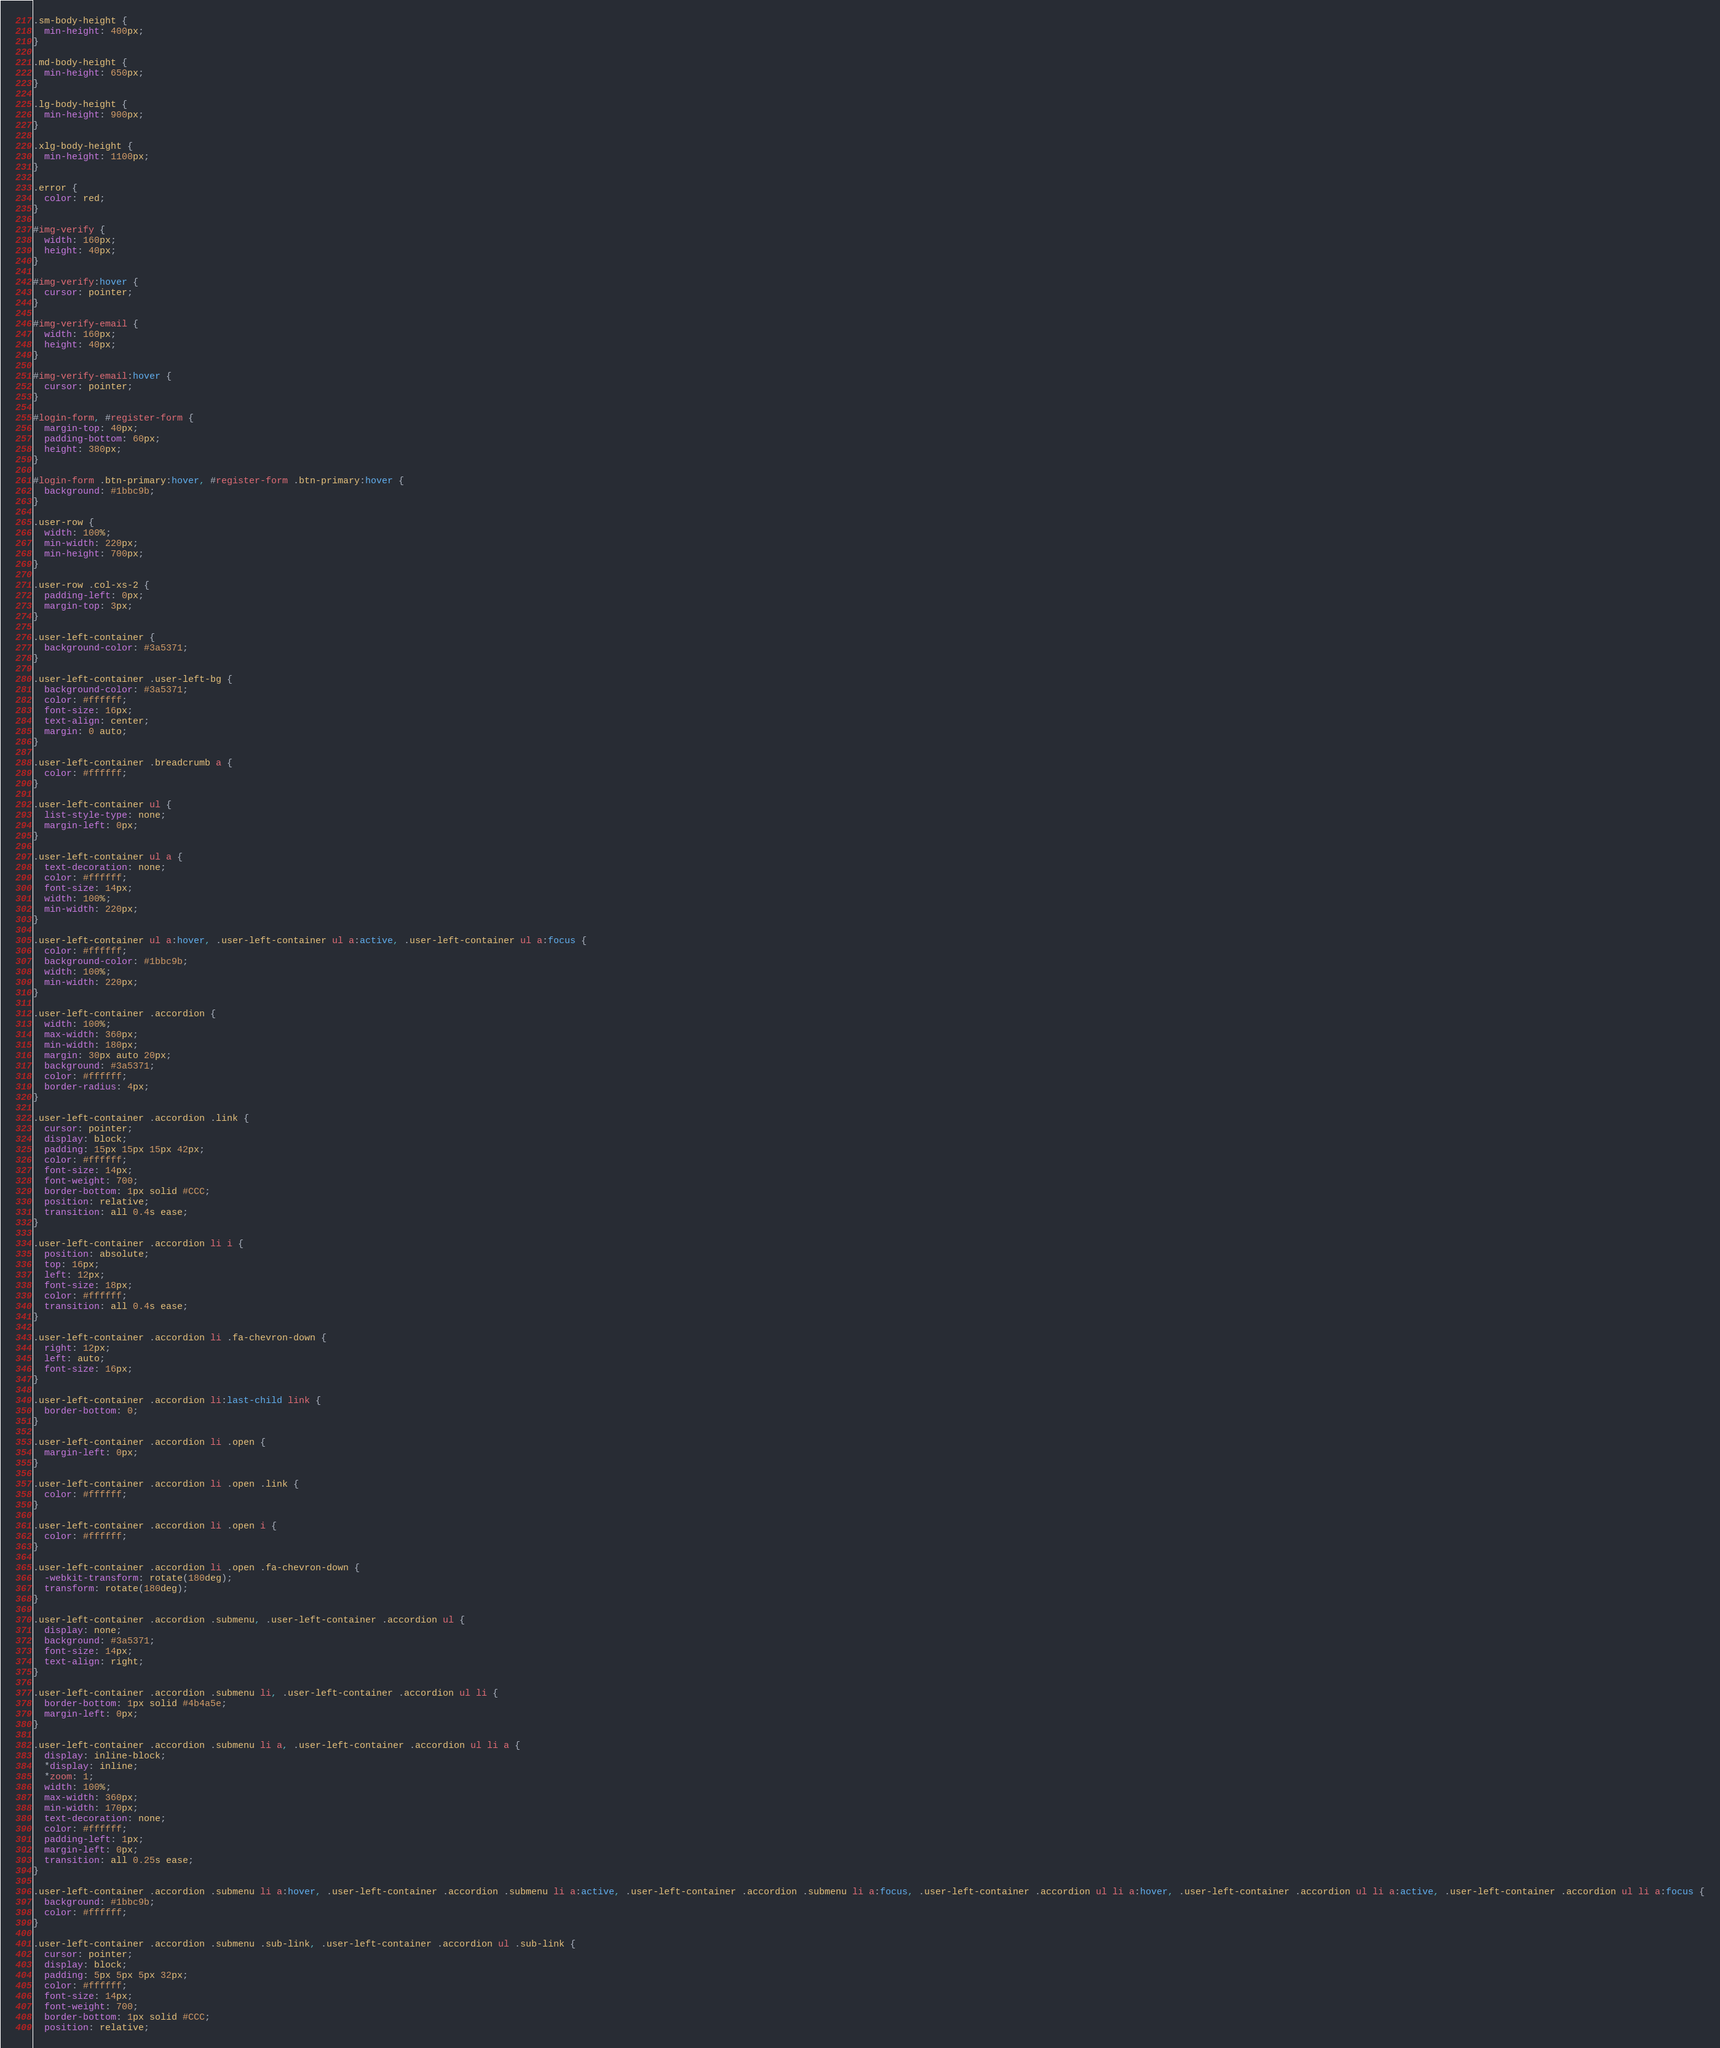Convert code to text. <code><loc_0><loc_0><loc_500><loc_500><_CSS_>.sm-body-height {
  min-height: 400px;
}

.md-body-height {
  min-height: 650px;
}

.lg-body-height {
  min-height: 900px;
}

.xlg-body-height {
  min-height: 1100px;
}

.error {
  color: red;
}

#img-verify {
  width: 160px;
  height: 40px;
}

#img-verify:hover {
  cursor: pointer;
}

#img-verify-email {
  width: 160px;
  height: 40px;
}

#img-verify-email:hover {
  cursor: pointer;
}

#login-form, #register-form {
  margin-top: 40px;
  padding-bottom: 60px;
  height: 380px;
}

#login-form .btn-primary:hover, #register-form .btn-primary:hover {
  background: #1bbc9b;
}

.user-row {
  width: 100%;
  min-width: 220px;
  min-height: 700px;
}

.user-row .col-xs-2 {
  padding-left: 0px;
  margin-top: 3px;
}

.user-left-container {
  background-color: #3a5371;
}

.user-left-container .user-left-bg {
  background-color: #3a5371;
  color: #ffffff;
  font-size: 16px;
  text-align: center;
  margin: 0 auto;
}

.user-left-container .breadcrumb a {
  color: #ffffff;
}

.user-left-container ul {
  list-style-type: none;
  margin-left: 0px;
}

.user-left-container ul a {
  text-decoration: none;
  color: #ffffff;
  font-size: 14px;
  width: 100%;
  min-width: 220px;
}

.user-left-container ul a:hover, .user-left-container ul a:active, .user-left-container ul a:focus {
  color: #ffffff;
  background-color: #1bbc9b;
  width: 100%;
  min-width: 220px;
}

.user-left-container .accordion {
  width: 100%;
  max-width: 360px;
  min-width: 180px;
  margin: 30px auto 20px;
  background: #3a5371;
  color: #ffffff;
  border-radius: 4px;
}

.user-left-container .accordion .link {
  cursor: pointer;
  display: block;
  padding: 15px 15px 15px 42px;
  color: #ffffff;
  font-size: 14px;
  font-weight: 700;
  border-bottom: 1px solid #CCC;
  position: relative;
  transition: all 0.4s ease;
}

.user-left-container .accordion li i {
  position: absolute;
  top: 16px;
  left: 12px;
  font-size: 18px;
  color: #ffffff;
  transition: all 0.4s ease;
}

.user-left-container .accordion li .fa-chevron-down {
  right: 12px;
  left: auto;
  font-size: 16px;
}

.user-left-container .accordion li:last-child link {
  border-bottom: 0;
}

.user-left-container .accordion li .open {
  margin-left: 0px;
}

.user-left-container .accordion li .open .link {
  color: #ffffff;
}

.user-left-container .accordion li .open i {
  color: #ffffff;
}

.user-left-container .accordion li .open .fa-chevron-down {
  -webkit-transform: rotate(180deg);
  transform: rotate(180deg);
}

.user-left-container .accordion .submenu, .user-left-container .accordion ul {
  display: none;
  background: #3a5371;
  font-size: 14px;
  text-align: right;
}

.user-left-container .accordion .submenu li, .user-left-container .accordion ul li {
  border-bottom: 1px solid #4b4a5e;
  margin-left: 0px;
}

.user-left-container .accordion .submenu li a, .user-left-container .accordion ul li a {
  display: inline-block;
  *display: inline;
  *zoom: 1;
  width: 100%;
  max-width: 360px;
  min-width: 170px;
  text-decoration: none;
  color: #ffffff;
  padding-left: 1px;
  margin-left: 0px;
  transition: all 0.25s ease;
}

.user-left-container .accordion .submenu li a:hover, .user-left-container .accordion .submenu li a:active, .user-left-container .accordion .submenu li a:focus, .user-left-container .accordion ul li a:hover, .user-left-container .accordion ul li a:active, .user-left-container .accordion ul li a:focus {
  background: #1bbc9b;
  color: #ffffff;
}

.user-left-container .accordion .submenu .sub-link, .user-left-container .accordion ul .sub-link {
  cursor: pointer;
  display: block;
  padding: 5px 5px 5px 32px;
  color: #ffffff;
  font-size: 14px;
  font-weight: 700;
  border-bottom: 1px solid #CCC;
  position: relative;</code> 